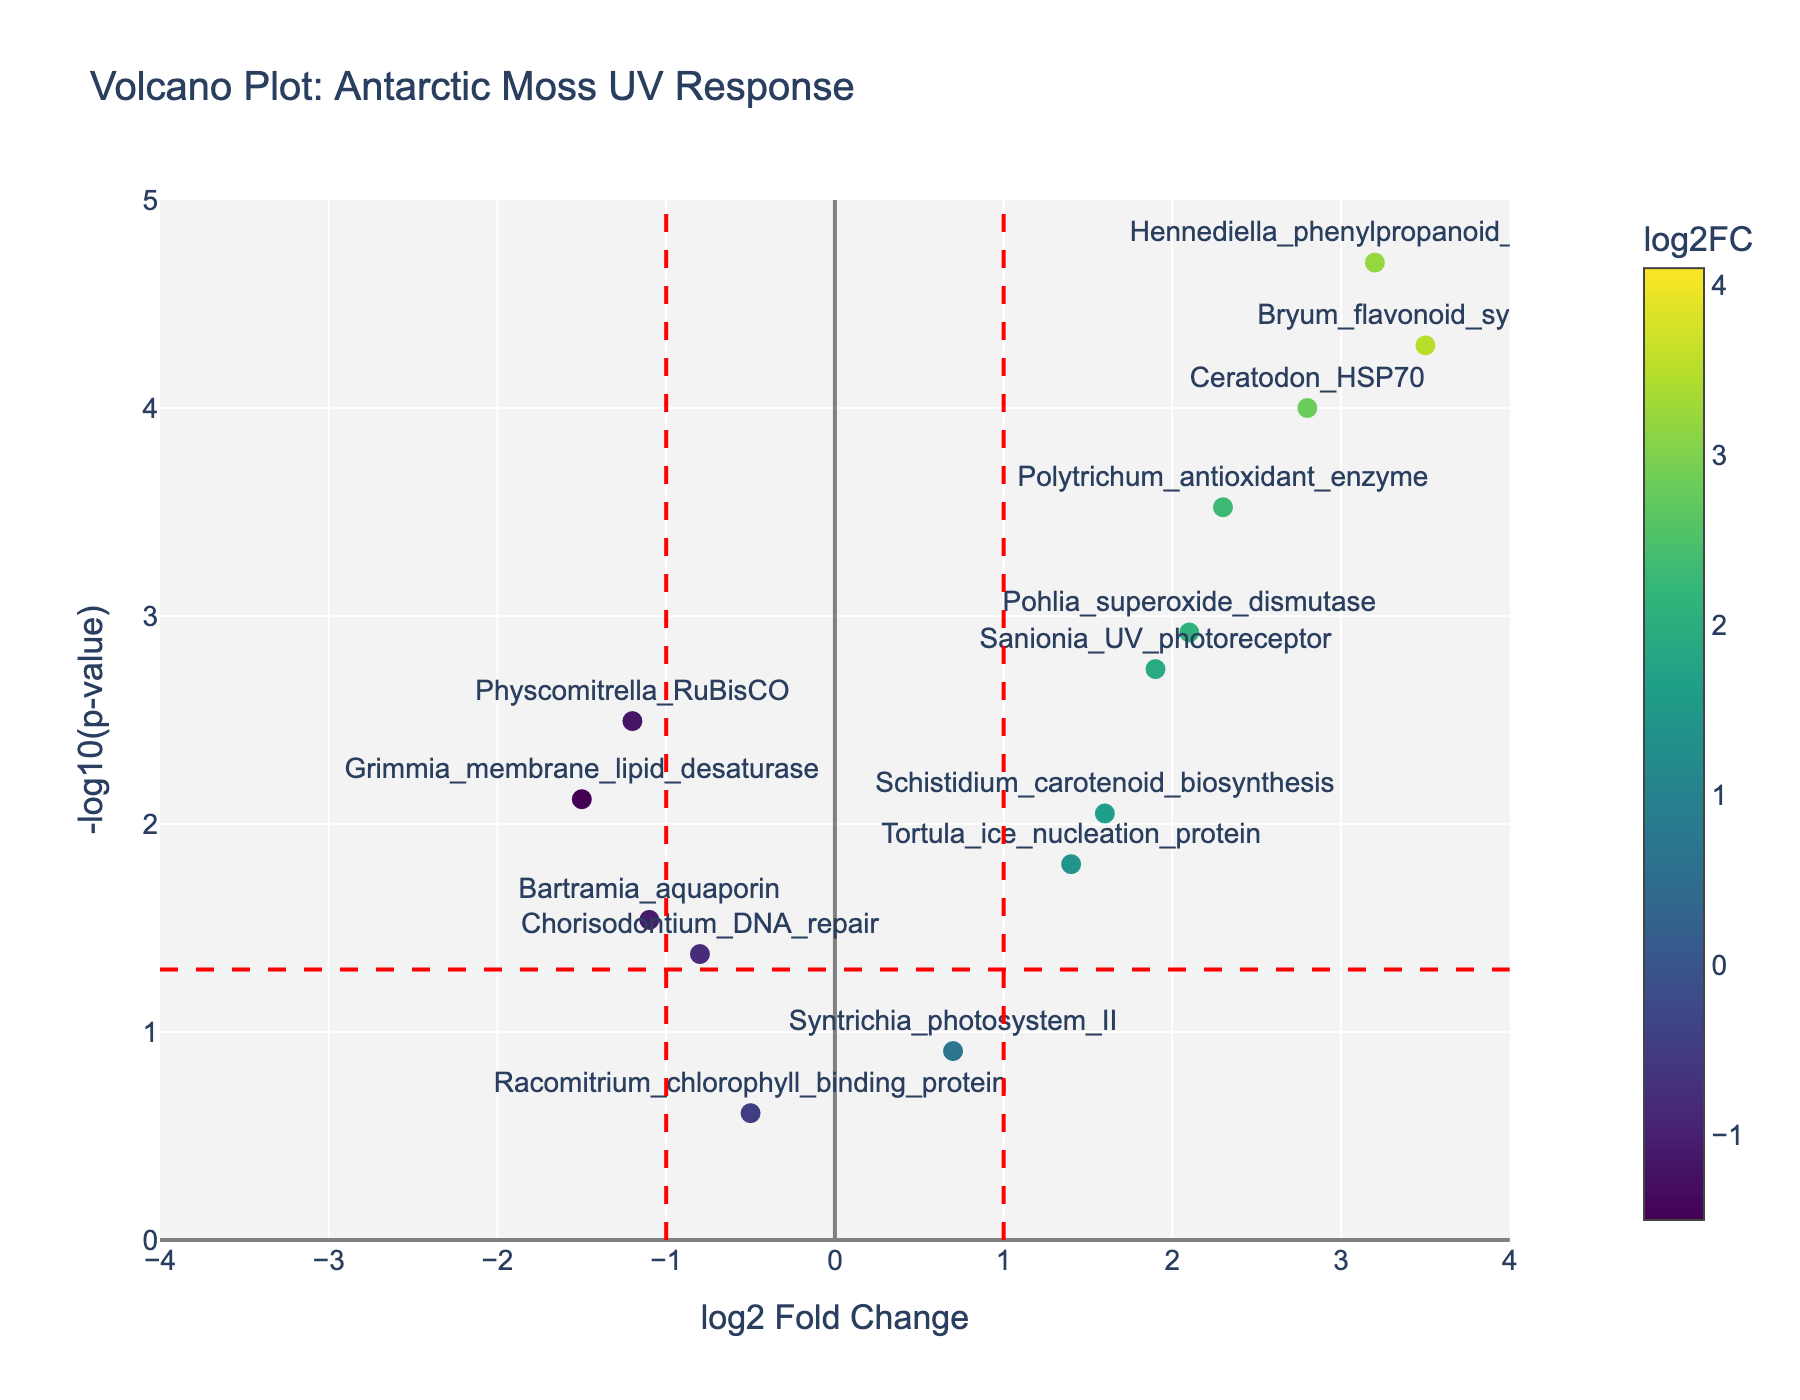What's the title of the plot? The title of the plot is mentioned at the top of the figure.
Answer: Volcano Plot: Antarctic Moss UV Response What are the x-axis and y-axis labels? The x-axis label is "log2 Fold Change" and the y-axis label is "-log10(p-value)", which are displayed along the respective axes.
Answer: log2 Fold Change and -log10(p-value) Which gene has the highest log2 fold change? By looking at the scatter plot, the gene with the highest x-value (log2FC) is Andreaea_dehydrin with a log2 fold change of 4.1.
Answer: Andreaea_dehydrin How many genes have a log2 fold change greater than 1? To find this, we count the number of points to the right of the vertical line at x=1. There are 6 genes: Ceratodon_HSP70, Bryum_flavonoid_synthase, Sanionia_UV_photoreceptor, Polytrichum_antioxidant_enzyme, Andreaea_dehydrin, and Hennediella_phenylpropanoid_pathway.
Answer: 6 Which gene has the most significant p-value? The most significant p-value corresponds to the highest value on the y-axis (-log10(p-value)). Andreaea_dehydrin has the highest y-value, indicating the lowest p-value.
Answer: Andreaea_dehydrin How many genes have a p-value less than 0.05? We look for points above the horizontal red dashed line (y=-log10(0.05)). There are 12 genes above this line.
Answer: 12 Which gene shows the strongest downregulation? Downregulation is indicated by the most negative log2 fold change. Grimmia_membrane_lipid_desaturase has the lowest log2FC of -1.5.
Answer: Grimmia_membrane_lipid_desaturase Which two genes have nearly the same p-value but opposite log2FC direction? By identifying points with similar y-values but different x-values, Ceratodon_HSP70 (log2FC=2.8) and Physcomitrella_RuBisCO (log2FC=-1.2) have similar p-values but opposite log2FC directions.
Answer: Ceratodon_HSP70 and Physcomitrella_RuBisCO Which gene related to photosystem activity is plotted, and how is it regulated? From the gene names, Syntrichia_photosystem_II relates to photosystem activity. It has a log2FC of 0.7, indicating slight upregulation, with a p-value greater than 0.05.
Answer: Syntrichia_photosystem_II, slight upregulation What is the log2 fold change and p-value of Bartramia_aquaporin? By referring to the hover text or looking for the label, Bartramia_aquaporin has a log2 fold change of -1.1 and a p-value of 0.0289.
Answer: -1.1 and 0.0289 